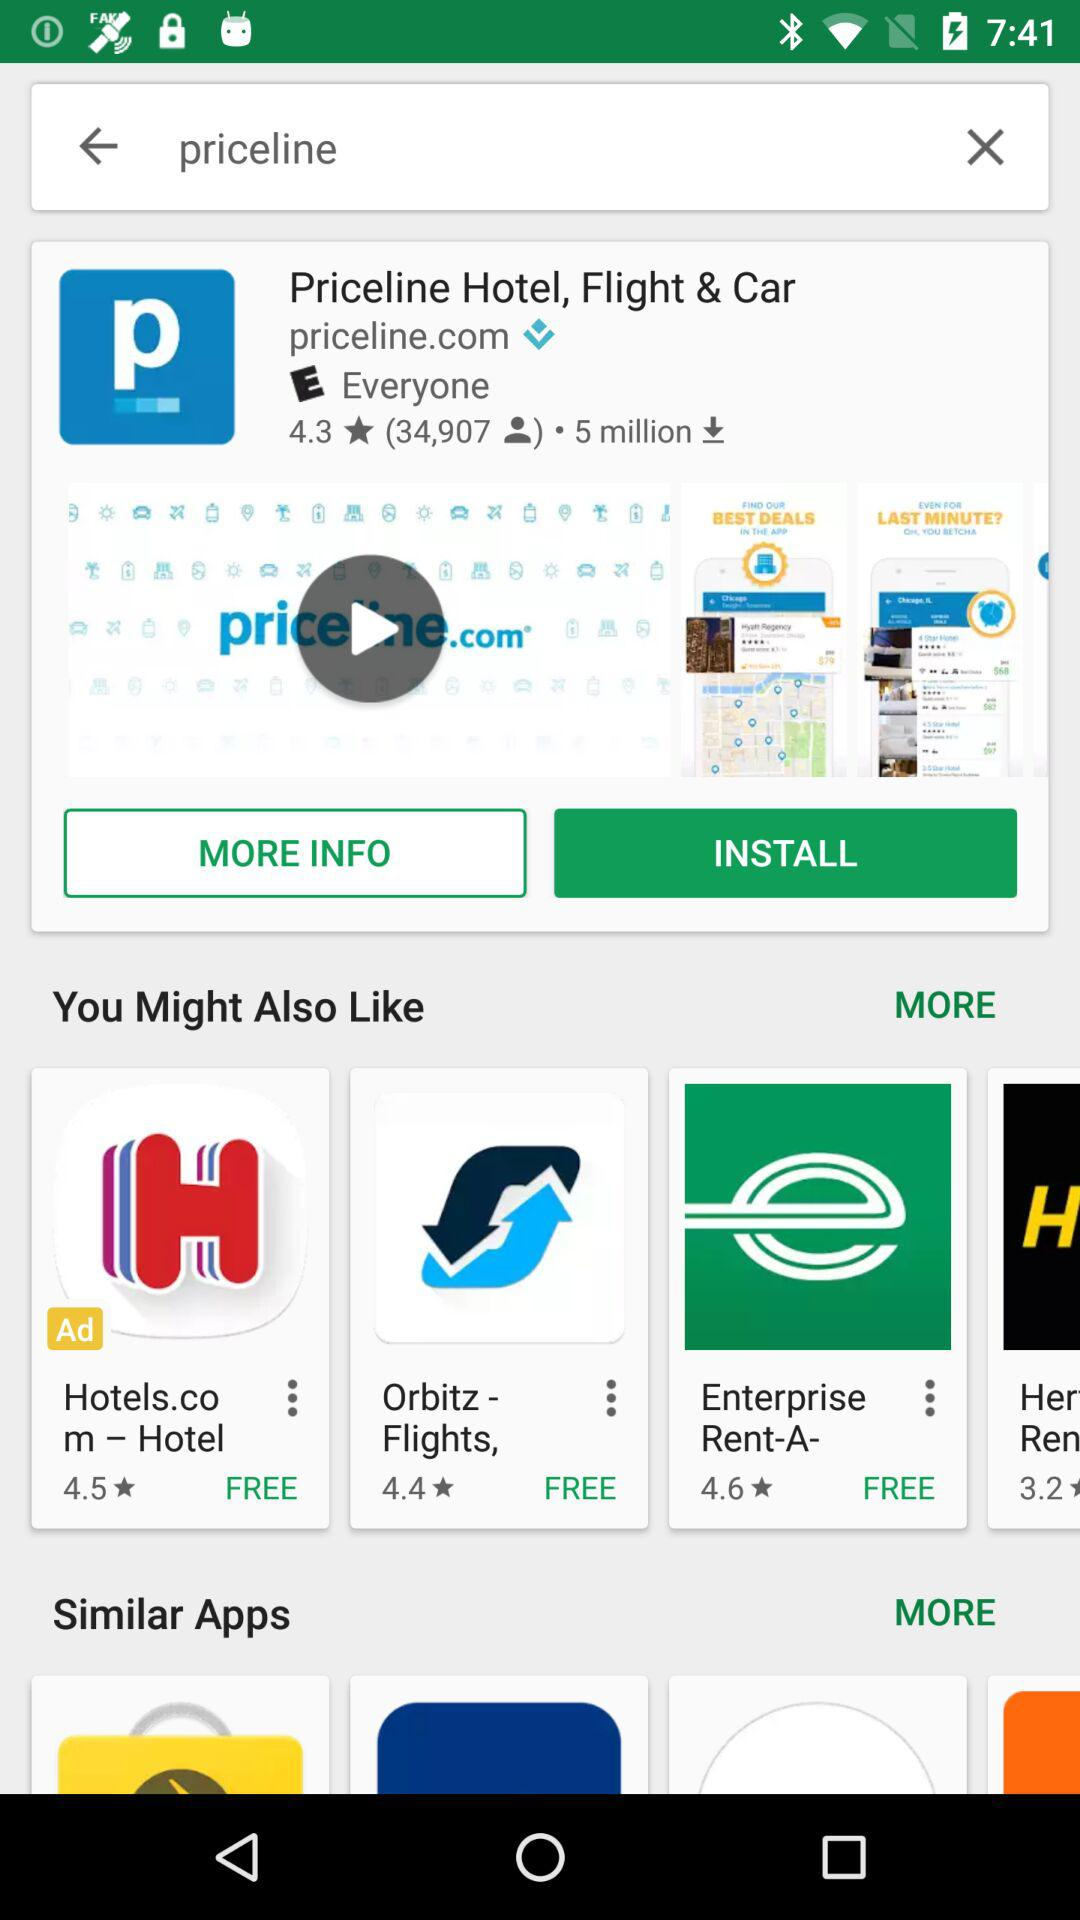How many people have reviewed it? The number of people who reviewed it is 34,907. 